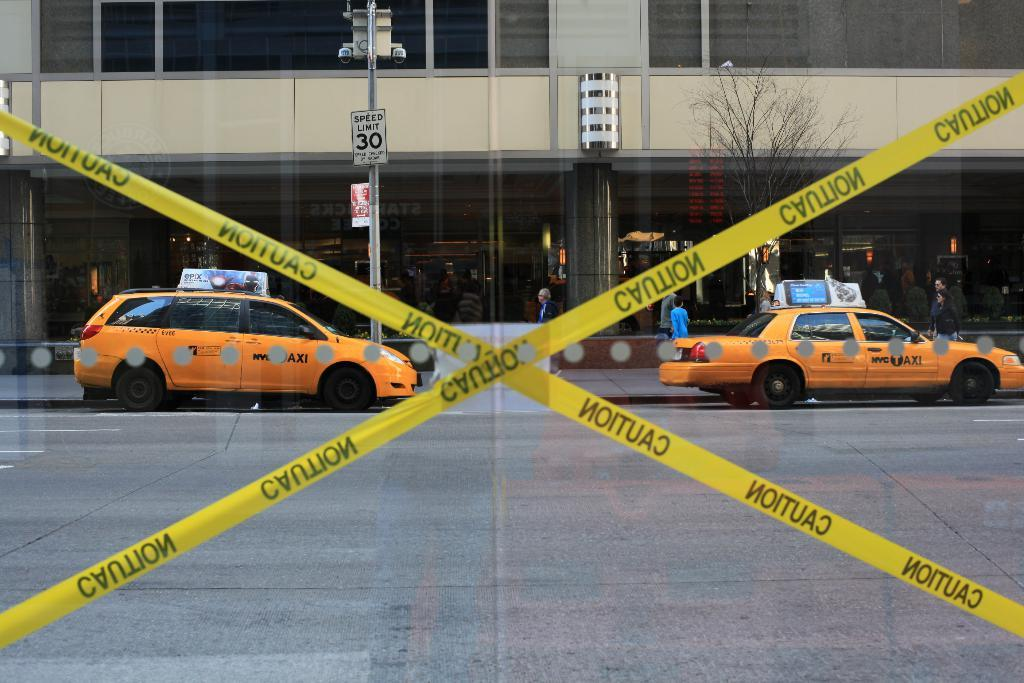<image>
Provide a brief description of the given image. Yellow police tape with caution written on it look spout on a street with taxis in it. 